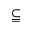<formula> <loc_0><loc_0><loc_500><loc_500>\subseteqq</formula> 